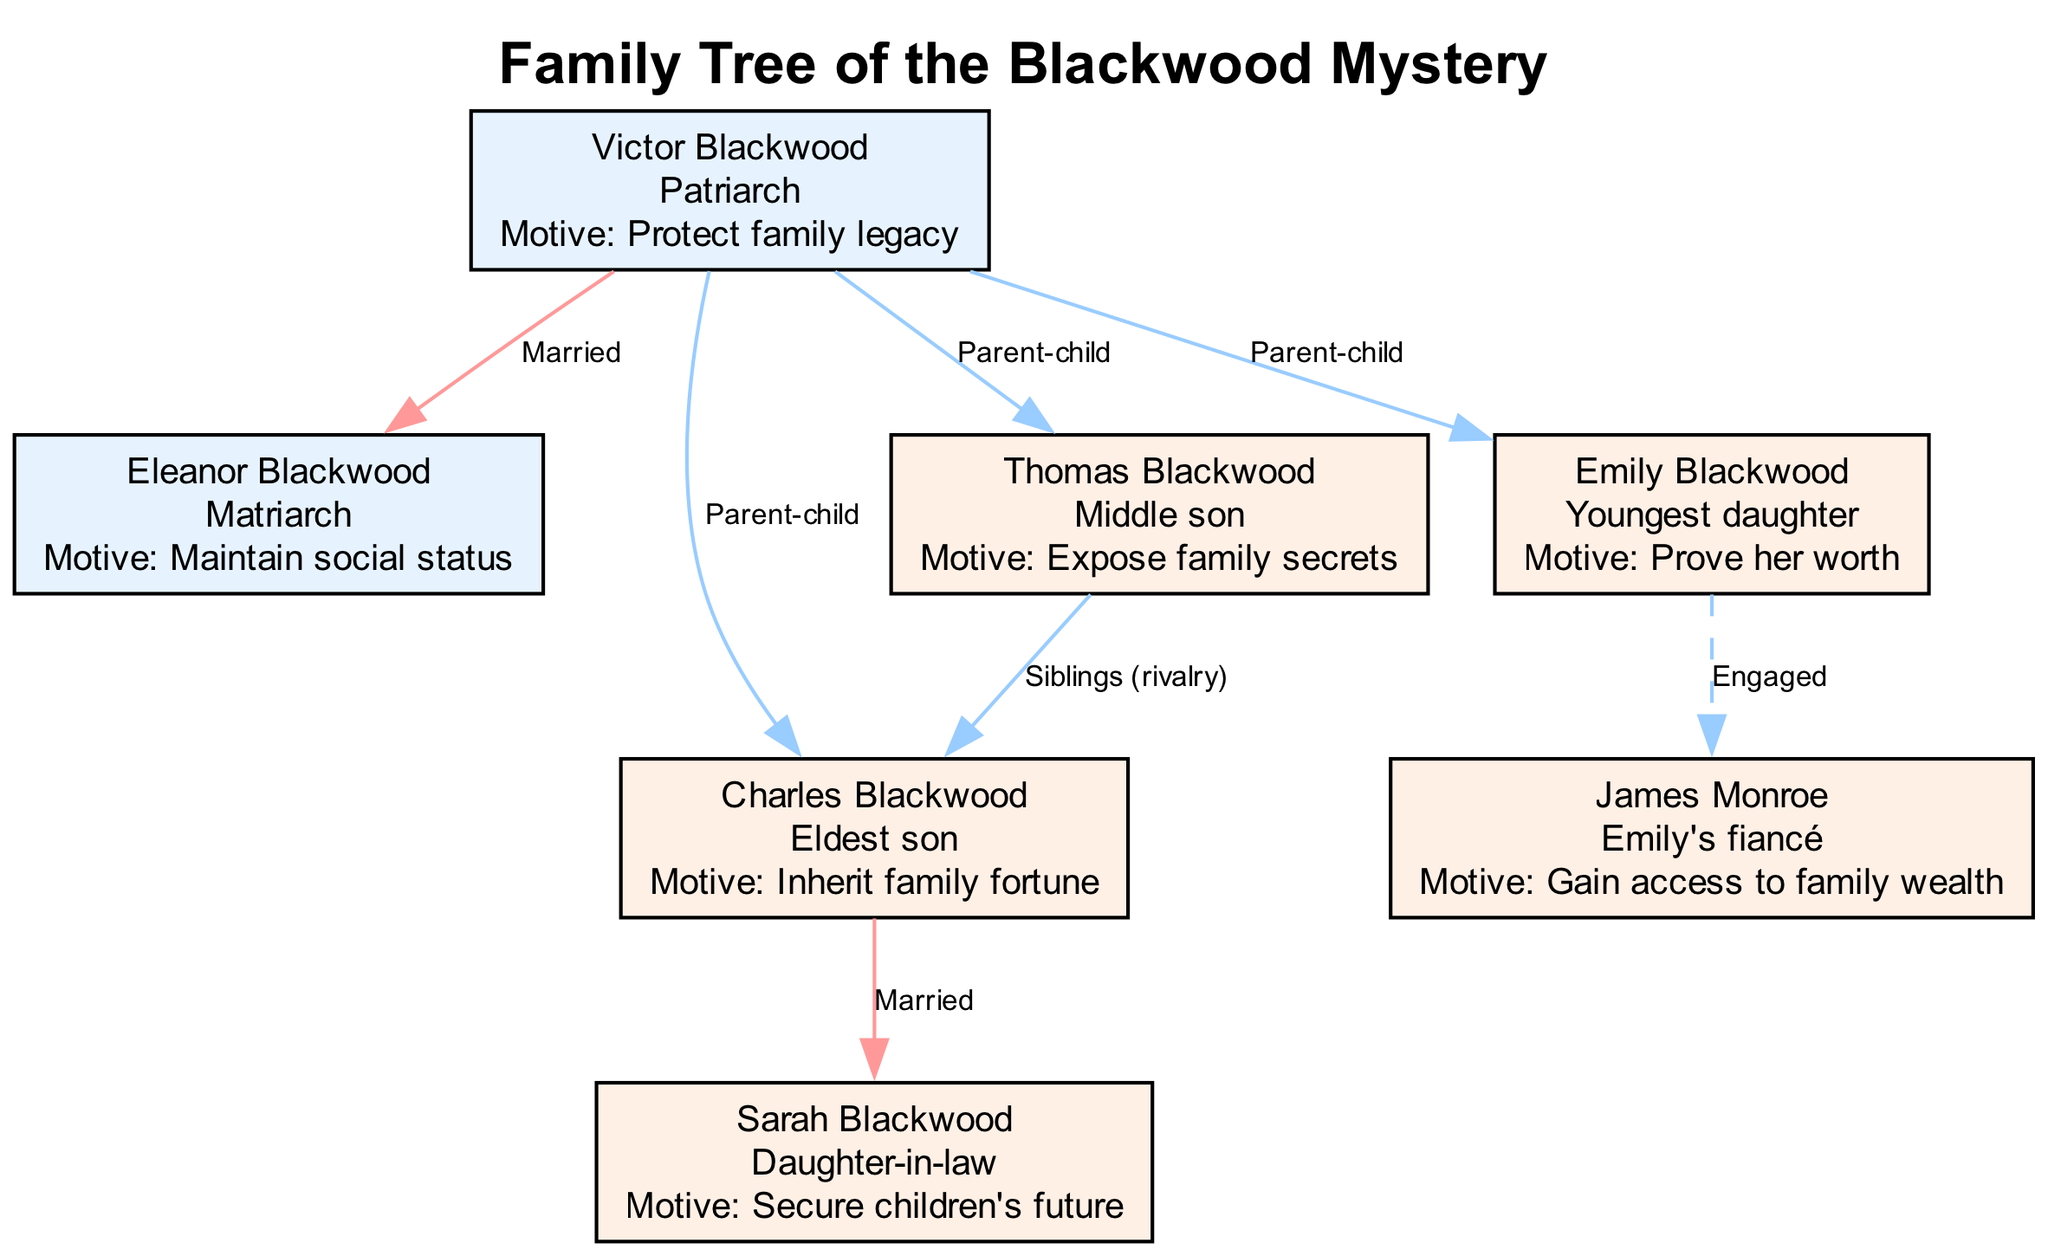What is the role of Victor Blackwood? In the diagram, Victor Blackwood is identified as the "Patriarch." This information is accessible directly from his node.
Answer: Patriarch How many children does Eleanor Blackwood have? By examining the edges emanating from Eleanor Blackwood, we can see that she is connected to Victor Blackwood, who has three children: Charles, Emily, and Thomas. Therefore, the total count is three children.
Answer: 3 What relationship exists between Charles Blackwood and Sarah Blackwood? The diagram clearly indicates that Charles Blackwood and Sarah Blackwood are connected with a "Married" relationship edge. This relationship type is depicted distinctly in the diagram.
Answer: Married What is Emily Blackwood’s motive? Looking at Emily Blackwood's node, her motive is listed as "Prove her worth." This information is directly available within her node for easy reference.
Answer: Prove her worth What is the motive of Thomas Blackwood? Thomas Blackwood's node specifies that his motive is to "Expose family secrets." This is a specific piece of information that corresponds exactly to his node in the diagram.
Answer: Expose family secrets How many nodes are connected to Victor Blackwood? Analyzing Victor Blackwood's node, we can observe that there are four edges connected to it, connecting to Eleanor, Charles, Emily, and Thomas. Thus, the count of connected nodes is four.
Answer: 4 What is the relationship between James Monroe and Emily Blackwood? The diagram displays an "Engaged" edge between James Monroe and Emily Blackwood, denoting their relationship type, which is a distinctive representation in this diagram.
Answer: Engaged Which node represents the matriarch of the family? From the diagram, Eleanor Blackwood's node is labeled "Matriarch," which directly identifies her role in the family tree.
Answer: Eleanor Blackwood Who are the siblings mentioned in the diagram? Examining the connections in the diagram, the siblings are identified as Charles Blackwood and Thomas Blackwood, indicated by their direct "Siblings (rivalry)" relationship edge in the layout.
Answer: Charles Blackwood and Thomas Blackwood 